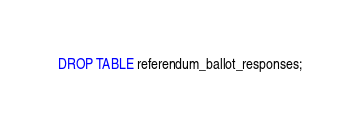<code> <loc_0><loc_0><loc_500><loc_500><_SQL_>DROP TABLE referendum_ballot_responses;
</code> 